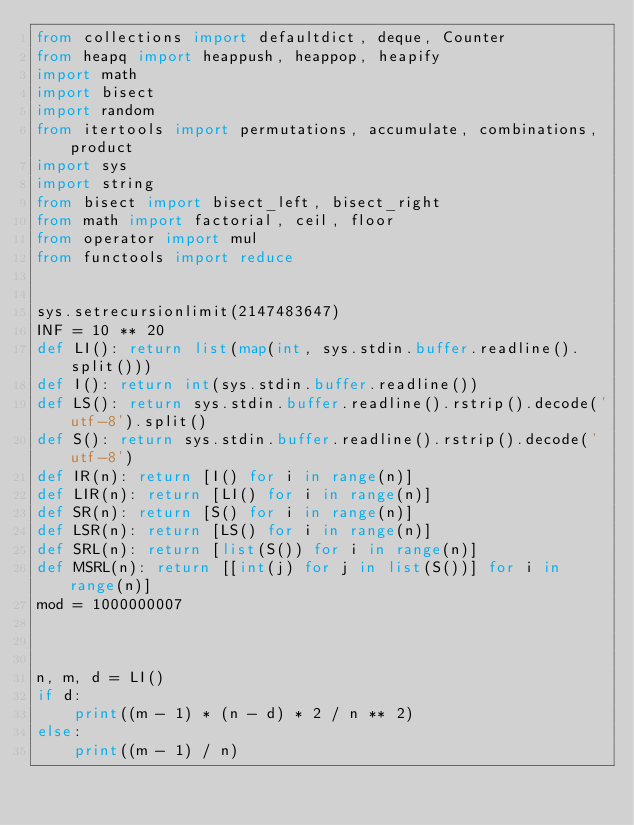Convert code to text. <code><loc_0><loc_0><loc_500><loc_500><_Python_>from collections import defaultdict, deque, Counter
from heapq import heappush, heappop, heapify
import math
import bisect
import random
from itertools import permutations, accumulate, combinations, product
import sys
import string
from bisect import bisect_left, bisect_right
from math import factorial, ceil, floor
from operator import mul
from functools import reduce


sys.setrecursionlimit(2147483647)
INF = 10 ** 20
def LI(): return list(map(int, sys.stdin.buffer.readline().split()))
def I(): return int(sys.stdin.buffer.readline())
def LS(): return sys.stdin.buffer.readline().rstrip().decode('utf-8').split()
def S(): return sys.stdin.buffer.readline().rstrip().decode('utf-8')
def IR(n): return [I() for i in range(n)]
def LIR(n): return [LI() for i in range(n)]
def SR(n): return [S() for i in range(n)]
def LSR(n): return [LS() for i in range(n)]
def SRL(n): return [list(S()) for i in range(n)]
def MSRL(n): return [[int(j) for j in list(S())] for i in range(n)]
mod = 1000000007



n, m, d = LI()
if d:
    print((m - 1) * (n - d) * 2 / n ** 2)
else:
    print((m - 1) / n)</code> 